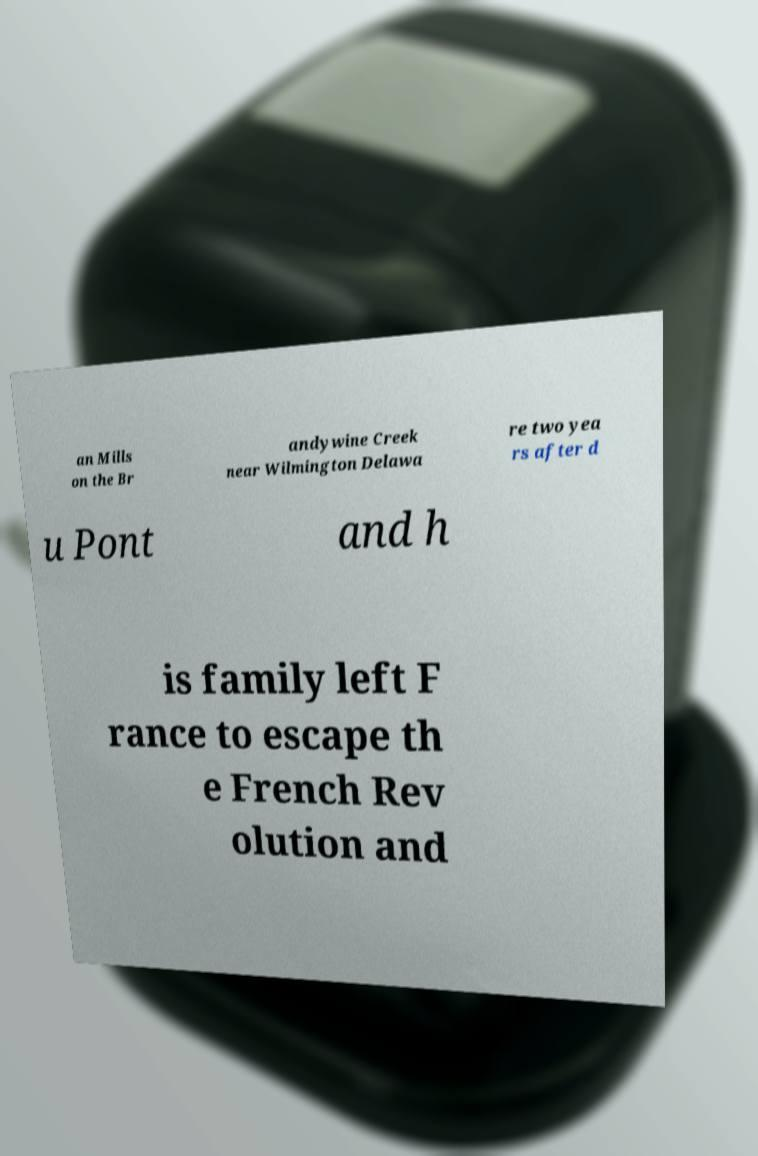Could you extract and type out the text from this image? an Mills on the Br andywine Creek near Wilmington Delawa re two yea rs after d u Pont and h is family left F rance to escape th e French Rev olution and 